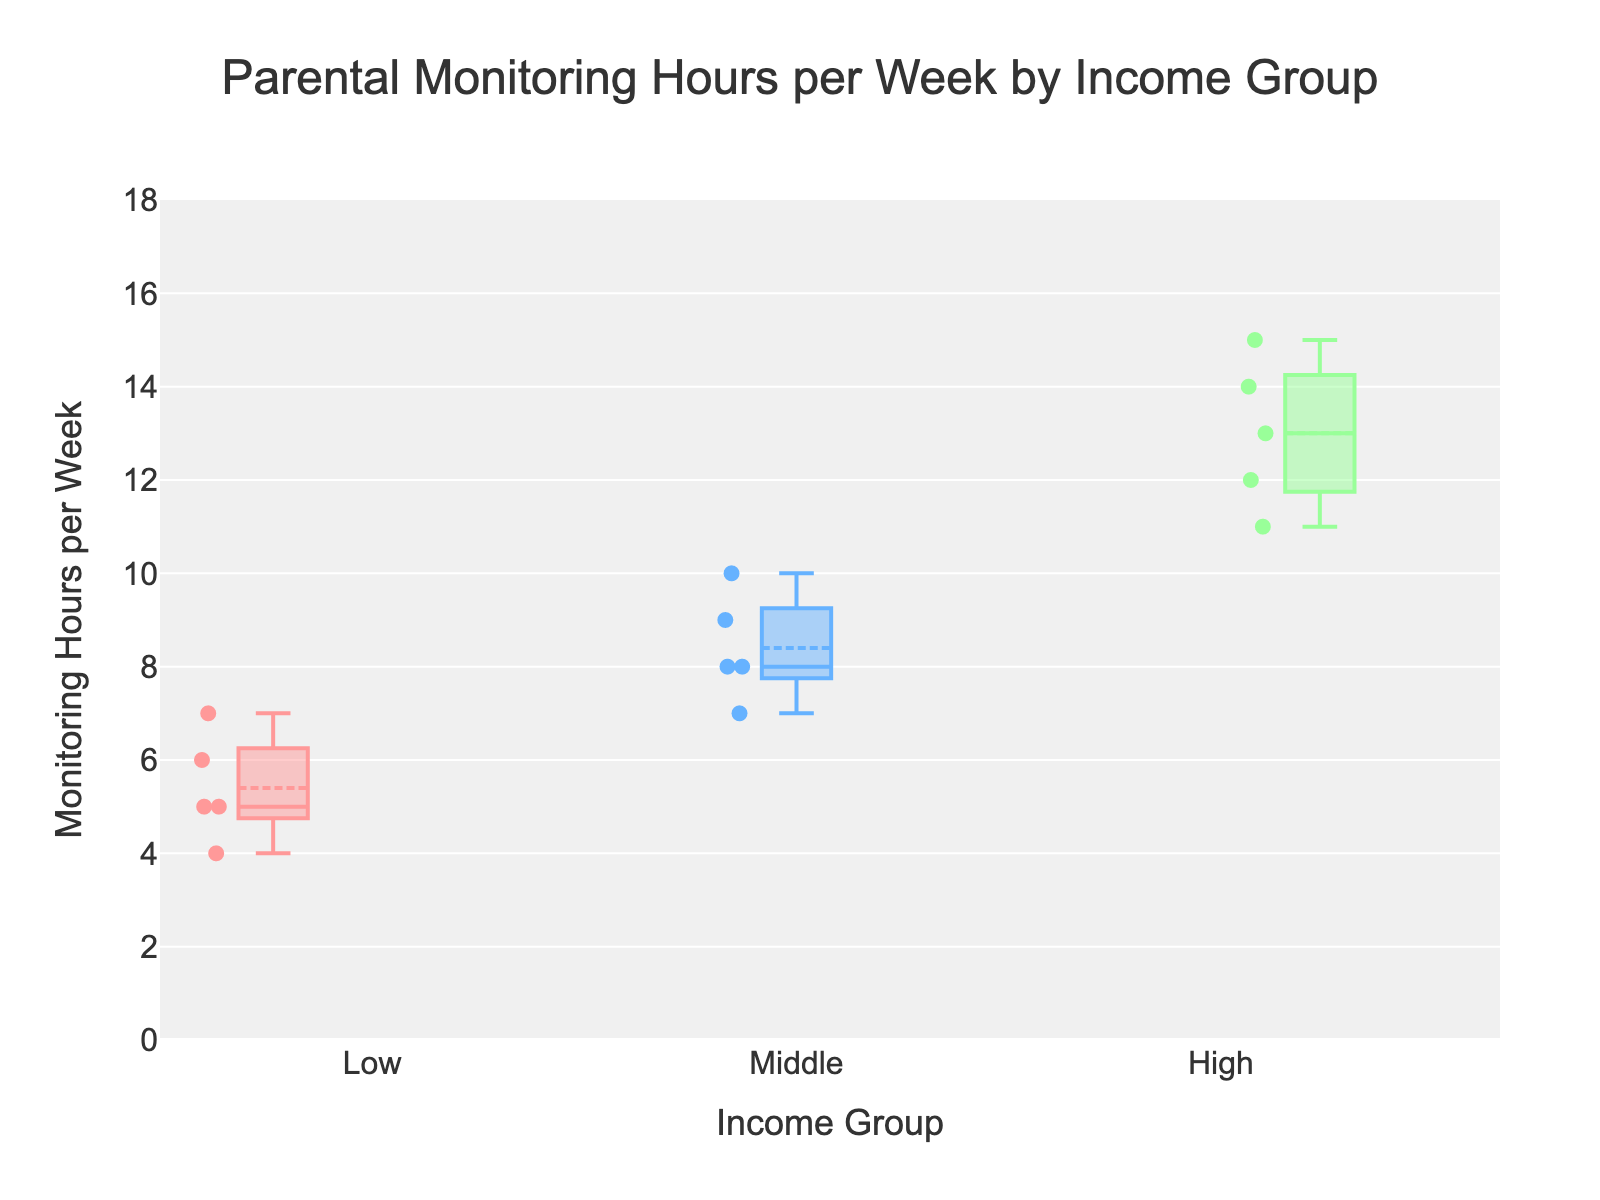What is the title of the plot? The title is usually placed at the top of the plot and provides a brief description of the content. Here, it reads "Parental Monitoring Hours per Week by Income Group"
Answer: Parental Monitoring Hours per Week by Income Group What is the y-axis title? Axis titles give context to the data being represented. The y-axis title is "Monitoring Hours per Week" as it indicates the metric being measured on this axis
Answer: Monitoring Hours per Week Which income group has the highest median value for monitoring hours per week? The median is represented by the line inside the box of the box plot, and for the High-income group, the median line appears the highest
Answer: High What is the approximate range of monitoring hours per week for the Middle income group? Look at the Middle group's box plot, noting the bottom and top whiskers, which likely range from 7 to 10
Answer: 7 to 10 hours Compare the interquartile range (IQR) of the Low income group to the High income group. The interquartile range is the range between the first quartile (bottom of the box) and the third quartile (top of the box). The Low income group has a smaller IQR compared to the larger IQR of the High income group
Answer: High has a larger IQR How do the parenting monitoring practices differ across income groups according to the plot? Analyzing all three box plots, it's evident that higher income groups tend to spend more hours on parental monitoring. The spread also increases with income
Answer: Higher income groups spend more hours monitoring Which income group shows the most variation in monitoring hours per week? Variation can be assessed by the overall length of the box (IQR) and the whiskers in the box plot. The High-income group shows the most variation due to its larger spread
Answer: High What are the maximum and minimum points (whiskers) for the Low income group? In the box plot, maximum and minimum points are shown by the whiskers. For the Low income group, they appear to be 7 and 4 respectively
Answer: Maximum: 7, Minimum: 4 What visual features indicate that the plot is a box plot? Box plots typically have boxes representing the IQR, lines within the boxes for median values, and whiskers extending from the boxes to indicate variability outside the upper and lower quartiles. This plot features all these elements
Answer: Boxes, median lines, whiskers What can you infer about the average monitoring hours per week for each income group? The boxes include a horizontal line for the mean and for the Median; the High-income group's average line appears substantially higher compared to Middle and Low groups
Answer: High group average is highest, then Middle, Low 